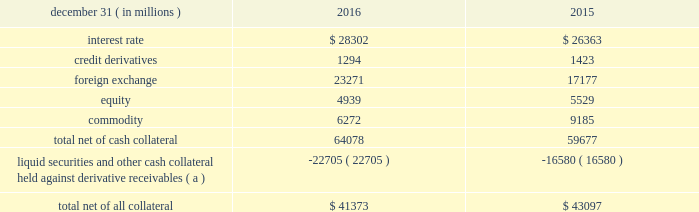Management 2019s discussion and analysis 102 jpmorgan chase & co./2016 annual report derivative contracts in the normal course of business , the firm uses derivative instruments predominantly for market-making activities .
Derivatives enable customers to manage exposures to fluctuations in interest rates , currencies and other markets .
The firm also uses derivative instruments to manage its own credit and other market risk exposure .
The nature of the counterparty and the settlement mechanism of the derivative affect the credit risk to which the firm is exposed .
For otc derivatives the firm is exposed to the credit risk of the derivative counterparty .
For exchange- traded derivatives ( 201cetd 201d ) , such as futures and options and 201ccleared 201d over-the-counter ( 201cotc-cleared 201d ) derivatives , the firm is generally exposed to the credit risk of the relevant ccp .
Where possible , the firm seeks to mitigate its credit risk exposures arising from derivative transactions through the use of legally enforceable master netting arrangements and collateral agreements .
For further discussion of derivative contracts , counterparties and settlement types , see note 6 .
The table summarizes the net derivative receivables for the periods presented .
Derivative receivables .
( a ) includes collateral related to derivative instruments where an appropriate legal opinion has not been either sought or obtained .
Derivative receivables reported on the consolidated balance sheets were $ 64.1 billion and $ 59.7 billion at december 31 , 2016 and 2015 , respectively .
These amounts represent the fair value of the derivative contracts after giving effect to legally enforceable master netting agreements and cash collateral held by the firm .
However , in management 2019s view , the appropriate measure of current credit risk should also take into consideration additional liquid securities ( primarily u.s .
Government and agency securities and other group of seven nations ( 201cg7 201d ) government bonds ) and other cash collateral held by the firm aggregating $ 22.7 billion and $ 16.6 billion at december 31 , 2016 and 2015 , respectively , that may be used as security when the fair value of the client 2019s exposure is in the firm 2019s favor .
The change in derivative receivables was predominantly related to client-driven market-making activities in cib .
The increase in derivative receivables reflected the impact of market movements , which increased foreign exchange receivables , partially offset by reduced commodity derivative receivables .
In addition to the collateral described in the preceding paragraph , the firm also holds additional collateral ( primarily cash , g7 government securities , other liquid government-agency and guaranteed securities , and corporate debt and equity securities ) delivered by clients at the initiation of transactions , as well as collateral related to contracts that have a non-daily call frequency and collateral that the firm has agreed to return but has not yet settled as of the reporting date .
Although this collateral does not reduce the balances and is not included in the table above , it is available as security against potential exposure that could arise should the fair value of the client 2019s derivative transactions move in the firm 2019s favor .
The derivative receivables fair value , net of all collateral , also does not include other credit enhancements , such as letters of credit .
For additional information on the firm 2019s use of collateral agreements , see note 6 .
While useful as a current view of credit exposure , the net fair value of the derivative receivables does not capture the potential future variability of that credit exposure .
To capture the potential future variability of credit exposure , the firm calculates , on a client-by-client basis , three measures of potential derivatives-related credit loss : peak , derivative risk equivalent ( 201cdre 201d ) , and average exposure ( 201cavg 201d ) .
These measures all incorporate netting and collateral benefits , where applicable .
Peak represents a conservative measure of potential exposure to a counterparty calculated in a manner that is broadly equivalent to a 97.5% ( 97.5 % ) confidence level over the life of the transaction .
Peak is the primary measure used by the firm for setting of credit limits for derivative transactions , senior management reporting and derivatives exposure management .
Dre exposure is a measure that expresses the risk of derivative exposure on a basis intended to be equivalent to the risk of loan exposures .
Dre is a less extreme measure of potential credit loss than peak and is used for aggregating derivative credit risk exposures with loans and other credit risk .
Finally , avg is a measure of the expected fair value of the firm 2019s derivative receivables at future time periods , including the benefit of collateral .
Avg exposure over the total life of the derivative contract is used as the primary metric for pricing purposes and is used to calculate credit capital and the cva , as further described below .
The three year avg exposure was $ 31.1 billion and $ 32.4 billion at december 31 , 2016 and 2015 , respectively , compared with derivative receivables , net of all collateral , of $ 41.4 billion and $ 43.1 billion at december 31 , 2016 and 2015 , respectively .
The fair value of the firm 2019s derivative receivables incorporates an adjustment , the cva , to reflect the credit quality of counterparties .
The cva is based on the firm 2019s avg to a counterparty and the counterparty 2019s credit spread in the credit derivatives market .
The primary components of changes in cva are credit spreads , new deal activity or unwinds , and changes in the underlying market environment .
The firm believes that active risk management is essential to controlling the dynamic credit .
What was the net three year avg derivative liability exposure , in billions , for 2016? 
Rationale: der . assets less liabilities
Computations: (31.1 - 41.4)
Answer: -10.3. 